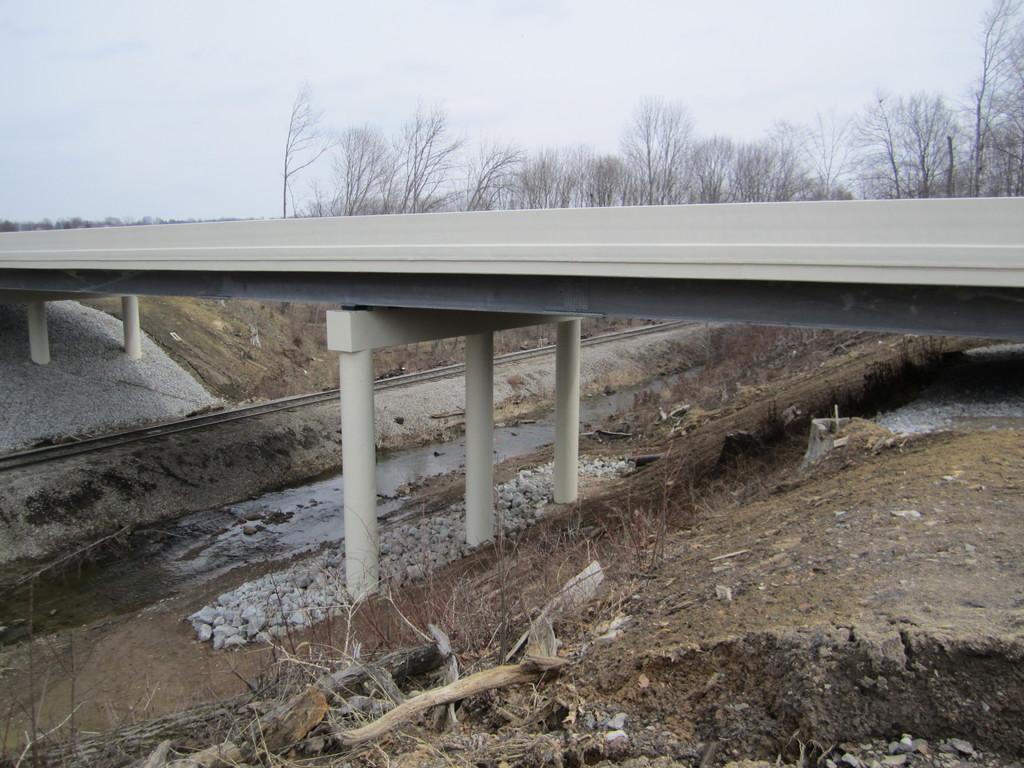Please provide a concise description of this image. In this image there is a bridge over the railway track, there are stones, trees, plants, wooden sticks and the sky. 